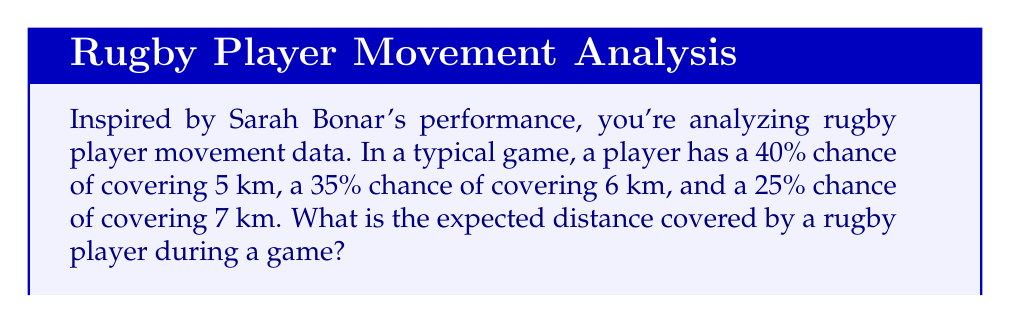Could you help me with this problem? Let's approach this step-by-step using the concept of expected value:

1) The expected value is calculated by multiplying each possible outcome by its probability and then summing these products.

2) Let's define our events:
   - Event A: covering 5 km with probability 0.40
   - Event B: covering 6 km with probability 0.35
   - Event C: covering 7 km with probability 0.25

3) The formula for expected value is:
   $$E(X) = \sum_{i=1}^{n} x_i \cdot p(x_i)$$
   where $x_i$ are the possible values and $p(x_i)$ are their respective probabilities.

4) Plugging in our values:
   $$E(X) = 5 \cdot 0.40 + 6 \cdot 0.35 + 7 \cdot 0.25$$

5) Let's calculate each term:
   $$E(X) = 2.00 + 2.10 + 1.75$$

6) Sum up the terms:
   $$E(X) = 5.85$$

Therefore, the expected distance covered by a rugby player during a game is 5.85 km.
Answer: 5.85 km 